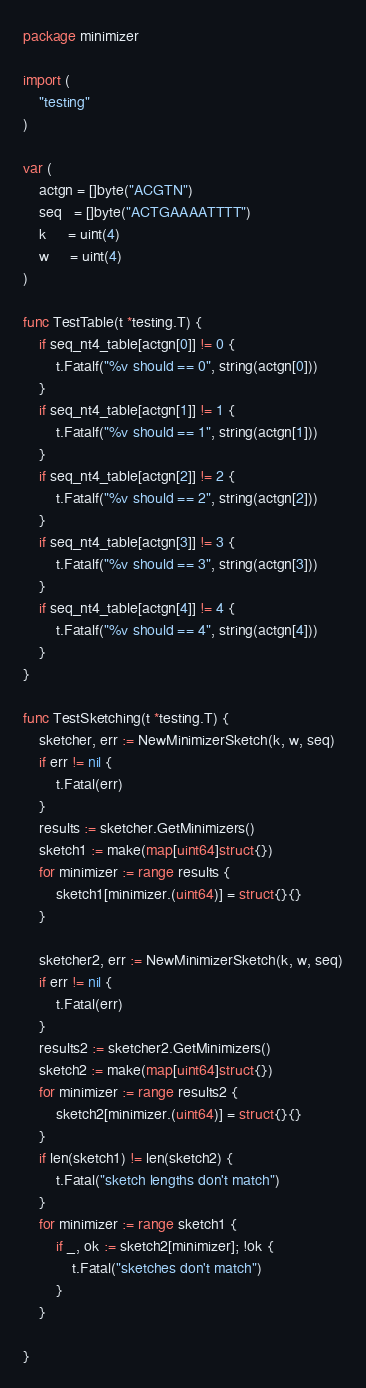Convert code to text. <code><loc_0><loc_0><loc_500><loc_500><_Go_>package minimizer

import (
	"testing"
)

var (
	actgn = []byte("ACGTN")
	seq   = []byte("ACTGAAAATTTT")
	k     = uint(4)
	w     = uint(4)
)

func TestTable(t *testing.T) {
	if seq_nt4_table[actgn[0]] != 0 {
		t.Fatalf("%v should == 0", string(actgn[0]))
	}
	if seq_nt4_table[actgn[1]] != 1 {
		t.Fatalf("%v should == 1", string(actgn[1]))
	}
	if seq_nt4_table[actgn[2]] != 2 {
		t.Fatalf("%v should == 2", string(actgn[2]))
	}
	if seq_nt4_table[actgn[3]] != 3 {
		t.Fatalf("%v should == 3", string(actgn[3]))
	}
	if seq_nt4_table[actgn[4]] != 4 {
		t.Fatalf("%v should == 4", string(actgn[4]))
	}
}

func TestSketching(t *testing.T) {
	sketcher, err := NewMinimizerSketch(k, w, seq)
	if err != nil {
		t.Fatal(err)
	}
	results := sketcher.GetMinimizers()
	sketch1 := make(map[uint64]struct{})
	for minimizer := range results {
		sketch1[minimizer.(uint64)] = struct{}{}
	}

	sketcher2, err := NewMinimizerSketch(k, w, seq)
	if err != nil {
		t.Fatal(err)
	}
	results2 := sketcher2.GetMinimizers()
	sketch2 := make(map[uint64]struct{})
	for minimizer := range results2 {
		sketch2[minimizer.(uint64)] = struct{}{}
	}
	if len(sketch1) != len(sketch2) {
		t.Fatal("sketch lengths don't match")
	}
	for minimizer := range sketch1 {
		if _, ok := sketch2[minimizer]; !ok {
			t.Fatal("sketches don't match")
		}
	}

}
</code> 